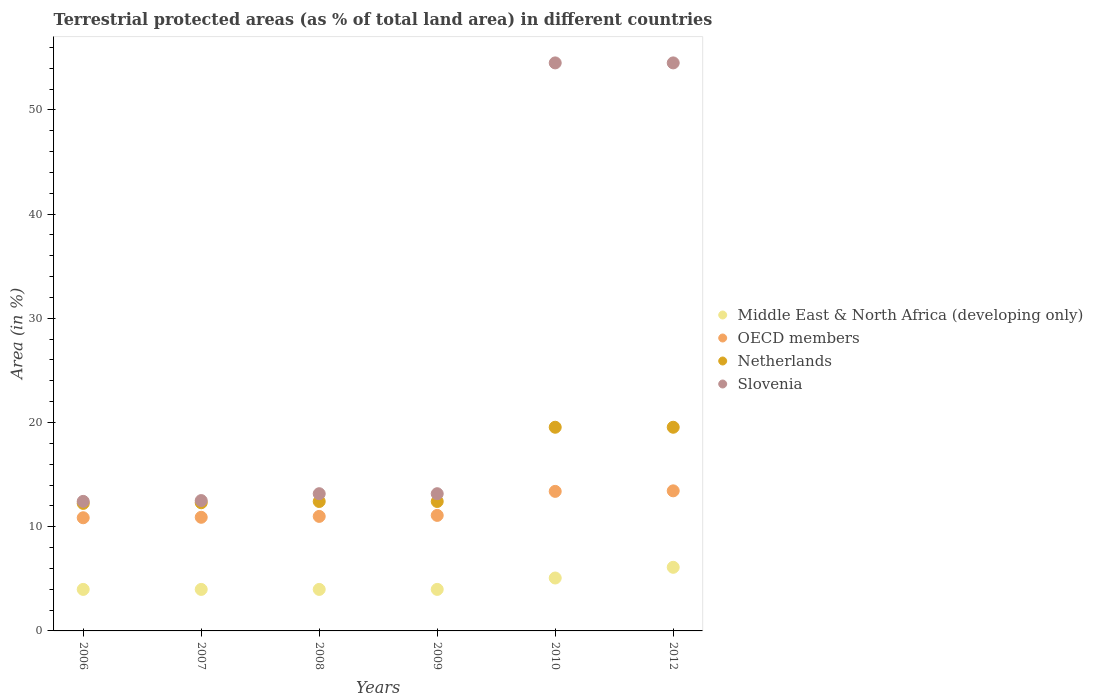What is the percentage of terrestrial protected land in Middle East & North Africa (developing only) in 2007?
Provide a succinct answer. 3.98. Across all years, what is the maximum percentage of terrestrial protected land in Slovenia?
Provide a short and direct response. 54.51. Across all years, what is the minimum percentage of terrestrial protected land in Netherlands?
Give a very brief answer. 12.24. In which year was the percentage of terrestrial protected land in Netherlands maximum?
Offer a terse response. 2010. What is the total percentage of terrestrial protected land in Slovenia in the graph?
Make the answer very short. 160.29. What is the difference between the percentage of terrestrial protected land in Netherlands in 2009 and that in 2012?
Your answer should be compact. -7.12. What is the difference between the percentage of terrestrial protected land in OECD members in 2009 and the percentage of terrestrial protected land in Slovenia in 2010?
Your answer should be compact. -43.42. What is the average percentage of terrestrial protected land in Netherlands per year?
Your answer should be very brief. 14.74. In the year 2007, what is the difference between the percentage of terrestrial protected land in Netherlands and percentage of terrestrial protected land in OECD members?
Provide a succinct answer. 1.4. In how many years, is the percentage of terrestrial protected land in Slovenia greater than 50 %?
Make the answer very short. 2. What is the ratio of the percentage of terrestrial protected land in Slovenia in 2009 to that in 2010?
Provide a succinct answer. 0.24. Is the percentage of terrestrial protected land in Middle East & North Africa (developing only) in 2009 less than that in 2010?
Provide a succinct answer. Yes. Is the difference between the percentage of terrestrial protected land in Netherlands in 2006 and 2012 greater than the difference between the percentage of terrestrial protected land in OECD members in 2006 and 2012?
Your answer should be compact. No. What is the difference between the highest and the second highest percentage of terrestrial protected land in Slovenia?
Make the answer very short. 0. What is the difference between the highest and the lowest percentage of terrestrial protected land in Slovenia?
Provide a short and direct response. 42.08. Is it the case that in every year, the sum of the percentage of terrestrial protected land in OECD members and percentage of terrestrial protected land in Netherlands  is greater than the sum of percentage of terrestrial protected land in Middle East & North Africa (developing only) and percentage of terrestrial protected land in Slovenia?
Offer a terse response. No. Is it the case that in every year, the sum of the percentage of terrestrial protected land in Slovenia and percentage of terrestrial protected land in Middle East & North Africa (developing only)  is greater than the percentage of terrestrial protected land in OECD members?
Make the answer very short. Yes. Is the percentage of terrestrial protected land in OECD members strictly greater than the percentage of terrestrial protected land in Middle East & North Africa (developing only) over the years?
Keep it short and to the point. Yes. Is the percentage of terrestrial protected land in OECD members strictly less than the percentage of terrestrial protected land in Middle East & North Africa (developing only) over the years?
Offer a very short reply. No. How many dotlines are there?
Your response must be concise. 4. How many years are there in the graph?
Your answer should be very brief. 6. What is the difference between two consecutive major ticks on the Y-axis?
Your answer should be very brief. 10. Are the values on the major ticks of Y-axis written in scientific E-notation?
Ensure brevity in your answer.  No. Where does the legend appear in the graph?
Your response must be concise. Center right. How many legend labels are there?
Your response must be concise. 4. What is the title of the graph?
Offer a terse response. Terrestrial protected areas (as % of total land area) in different countries. What is the label or title of the Y-axis?
Your answer should be very brief. Area (in %). What is the Area (in %) in Middle East & North Africa (developing only) in 2006?
Provide a short and direct response. 3.98. What is the Area (in %) of OECD members in 2006?
Provide a succinct answer. 10.86. What is the Area (in %) of Netherlands in 2006?
Make the answer very short. 12.24. What is the Area (in %) in Slovenia in 2006?
Offer a very short reply. 12.43. What is the Area (in %) in Middle East & North Africa (developing only) in 2007?
Provide a succinct answer. 3.98. What is the Area (in %) of OECD members in 2007?
Make the answer very short. 10.9. What is the Area (in %) in Netherlands in 2007?
Provide a succinct answer. 12.3. What is the Area (in %) of Slovenia in 2007?
Offer a very short reply. 12.51. What is the Area (in %) in Middle East & North Africa (developing only) in 2008?
Your answer should be compact. 3.98. What is the Area (in %) of OECD members in 2008?
Your answer should be very brief. 10.99. What is the Area (in %) of Netherlands in 2008?
Offer a very short reply. 12.42. What is the Area (in %) in Slovenia in 2008?
Keep it short and to the point. 13.17. What is the Area (in %) in Middle East & North Africa (developing only) in 2009?
Make the answer very short. 3.98. What is the Area (in %) of OECD members in 2009?
Ensure brevity in your answer.  11.09. What is the Area (in %) in Netherlands in 2009?
Your answer should be compact. 12.42. What is the Area (in %) of Slovenia in 2009?
Make the answer very short. 13.17. What is the Area (in %) of Middle East & North Africa (developing only) in 2010?
Offer a very short reply. 5.08. What is the Area (in %) in OECD members in 2010?
Give a very brief answer. 13.39. What is the Area (in %) of Netherlands in 2010?
Your response must be concise. 19.54. What is the Area (in %) of Slovenia in 2010?
Offer a terse response. 54.51. What is the Area (in %) of Middle East & North Africa (developing only) in 2012?
Your response must be concise. 6.1. What is the Area (in %) of OECD members in 2012?
Your answer should be compact. 13.44. What is the Area (in %) in Netherlands in 2012?
Provide a short and direct response. 19.54. What is the Area (in %) of Slovenia in 2012?
Make the answer very short. 54.51. Across all years, what is the maximum Area (in %) of Middle East & North Africa (developing only)?
Give a very brief answer. 6.1. Across all years, what is the maximum Area (in %) in OECD members?
Offer a terse response. 13.44. Across all years, what is the maximum Area (in %) in Netherlands?
Offer a terse response. 19.54. Across all years, what is the maximum Area (in %) in Slovenia?
Offer a terse response. 54.51. Across all years, what is the minimum Area (in %) of Middle East & North Africa (developing only)?
Offer a terse response. 3.98. Across all years, what is the minimum Area (in %) of OECD members?
Your answer should be very brief. 10.86. Across all years, what is the minimum Area (in %) in Netherlands?
Your response must be concise. 12.24. Across all years, what is the minimum Area (in %) in Slovenia?
Your response must be concise. 12.43. What is the total Area (in %) of Middle East & North Africa (developing only) in the graph?
Your response must be concise. 27.12. What is the total Area (in %) of OECD members in the graph?
Your answer should be compact. 70.67. What is the total Area (in %) of Netherlands in the graph?
Provide a succinct answer. 88.47. What is the total Area (in %) in Slovenia in the graph?
Ensure brevity in your answer.  160.29. What is the difference between the Area (in %) of Middle East & North Africa (developing only) in 2006 and that in 2007?
Provide a succinct answer. 0. What is the difference between the Area (in %) of OECD members in 2006 and that in 2007?
Give a very brief answer. -0.04. What is the difference between the Area (in %) in Netherlands in 2006 and that in 2007?
Offer a very short reply. -0.06. What is the difference between the Area (in %) of Slovenia in 2006 and that in 2007?
Make the answer very short. -0.08. What is the difference between the Area (in %) of OECD members in 2006 and that in 2008?
Your answer should be very brief. -0.13. What is the difference between the Area (in %) in Netherlands in 2006 and that in 2008?
Your response must be concise. -0.18. What is the difference between the Area (in %) in Slovenia in 2006 and that in 2008?
Make the answer very short. -0.74. What is the difference between the Area (in %) in Middle East & North Africa (developing only) in 2006 and that in 2009?
Offer a terse response. -0. What is the difference between the Area (in %) in OECD members in 2006 and that in 2009?
Your response must be concise. -0.23. What is the difference between the Area (in %) of Netherlands in 2006 and that in 2009?
Provide a succinct answer. -0.18. What is the difference between the Area (in %) of Slovenia in 2006 and that in 2009?
Provide a succinct answer. -0.74. What is the difference between the Area (in %) of Middle East & North Africa (developing only) in 2006 and that in 2010?
Your answer should be compact. -1.09. What is the difference between the Area (in %) of OECD members in 2006 and that in 2010?
Make the answer very short. -2.53. What is the difference between the Area (in %) of Netherlands in 2006 and that in 2010?
Offer a very short reply. -7.31. What is the difference between the Area (in %) of Slovenia in 2006 and that in 2010?
Provide a short and direct response. -42.08. What is the difference between the Area (in %) in Middle East & North Africa (developing only) in 2006 and that in 2012?
Make the answer very short. -2.12. What is the difference between the Area (in %) in OECD members in 2006 and that in 2012?
Offer a very short reply. -2.58. What is the difference between the Area (in %) in Netherlands in 2006 and that in 2012?
Provide a short and direct response. -7.31. What is the difference between the Area (in %) of Slovenia in 2006 and that in 2012?
Your answer should be very brief. -42.08. What is the difference between the Area (in %) in Middle East & North Africa (developing only) in 2007 and that in 2008?
Provide a short and direct response. 0. What is the difference between the Area (in %) in OECD members in 2007 and that in 2008?
Give a very brief answer. -0.09. What is the difference between the Area (in %) in Netherlands in 2007 and that in 2008?
Your response must be concise. -0.12. What is the difference between the Area (in %) in Slovenia in 2007 and that in 2008?
Your answer should be very brief. -0.66. What is the difference between the Area (in %) of Middle East & North Africa (developing only) in 2007 and that in 2009?
Provide a succinct answer. -0. What is the difference between the Area (in %) of OECD members in 2007 and that in 2009?
Your response must be concise. -0.18. What is the difference between the Area (in %) of Netherlands in 2007 and that in 2009?
Your answer should be very brief. -0.12. What is the difference between the Area (in %) of Slovenia in 2007 and that in 2009?
Provide a succinct answer. -0.66. What is the difference between the Area (in %) in Middle East & North Africa (developing only) in 2007 and that in 2010?
Give a very brief answer. -1.09. What is the difference between the Area (in %) in OECD members in 2007 and that in 2010?
Your answer should be very brief. -2.49. What is the difference between the Area (in %) of Netherlands in 2007 and that in 2010?
Your answer should be very brief. -7.25. What is the difference between the Area (in %) of Slovenia in 2007 and that in 2010?
Offer a terse response. -42. What is the difference between the Area (in %) of Middle East & North Africa (developing only) in 2007 and that in 2012?
Your answer should be compact. -2.12. What is the difference between the Area (in %) of OECD members in 2007 and that in 2012?
Your answer should be compact. -2.54. What is the difference between the Area (in %) of Netherlands in 2007 and that in 2012?
Ensure brevity in your answer.  -7.25. What is the difference between the Area (in %) of Slovenia in 2007 and that in 2012?
Your response must be concise. -42. What is the difference between the Area (in %) of Middle East & North Africa (developing only) in 2008 and that in 2009?
Provide a succinct answer. -0. What is the difference between the Area (in %) in OECD members in 2008 and that in 2009?
Offer a very short reply. -0.1. What is the difference between the Area (in %) in Netherlands in 2008 and that in 2009?
Ensure brevity in your answer.  0. What is the difference between the Area (in %) in Slovenia in 2008 and that in 2009?
Give a very brief answer. 0. What is the difference between the Area (in %) in Middle East & North Africa (developing only) in 2008 and that in 2010?
Your answer should be compact. -1.09. What is the difference between the Area (in %) in OECD members in 2008 and that in 2010?
Offer a very short reply. -2.4. What is the difference between the Area (in %) in Netherlands in 2008 and that in 2010?
Provide a succinct answer. -7.12. What is the difference between the Area (in %) in Slovenia in 2008 and that in 2010?
Offer a terse response. -41.34. What is the difference between the Area (in %) of Middle East & North Africa (developing only) in 2008 and that in 2012?
Offer a very short reply. -2.12. What is the difference between the Area (in %) of OECD members in 2008 and that in 2012?
Make the answer very short. -2.45. What is the difference between the Area (in %) in Netherlands in 2008 and that in 2012?
Keep it short and to the point. -7.12. What is the difference between the Area (in %) of Slovenia in 2008 and that in 2012?
Your answer should be compact. -41.34. What is the difference between the Area (in %) of Middle East & North Africa (developing only) in 2009 and that in 2010?
Your answer should be compact. -1.09. What is the difference between the Area (in %) of OECD members in 2009 and that in 2010?
Your response must be concise. -2.31. What is the difference between the Area (in %) in Netherlands in 2009 and that in 2010?
Provide a succinct answer. -7.12. What is the difference between the Area (in %) of Slovenia in 2009 and that in 2010?
Keep it short and to the point. -41.34. What is the difference between the Area (in %) of Middle East & North Africa (developing only) in 2009 and that in 2012?
Make the answer very short. -2.12. What is the difference between the Area (in %) in OECD members in 2009 and that in 2012?
Offer a terse response. -2.36. What is the difference between the Area (in %) in Netherlands in 2009 and that in 2012?
Keep it short and to the point. -7.12. What is the difference between the Area (in %) of Slovenia in 2009 and that in 2012?
Your response must be concise. -41.34. What is the difference between the Area (in %) of Middle East & North Africa (developing only) in 2010 and that in 2012?
Provide a short and direct response. -1.03. What is the difference between the Area (in %) in OECD members in 2010 and that in 2012?
Offer a terse response. -0.05. What is the difference between the Area (in %) in Middle East & North Africa (developing only) in 2006 and the Area (in %) in OECD members in 2007?
Keep it short and to the point. -6.92. What is the difference between the Area (in %) in Middle East & North Africa (developing only) in 2006 and the Area (in %) in Netherlands in 2007?
Ensure brevity in your answer.  -8.32. What is the difference between the Area (in %) of Middle East & North Africa (developing only) in 2006 and the Area (in %) of Slovenia in 2007?
Keep it short and to the point. -8.52. What is the difference between the Area (in %) of OECD members in 2006 and the Area (in %) of Netherlands in 2007?
Your answer should be compact. -1.44. What is the difference between the Area (in %) of OECD members in 2006 and the Area (in %) of Slovenia in 2007?
Keep it short and to the point. -1.65. What is the difference between the Area (in %) of Netherlands in 2006 and the Area (in %) of Slovenia in 2007?
Your answer should be very brief. -0.27. What is the difference between the Area (in %) in Middle East & North Africa (developing only) in 2006 and the Area (in %) in OECD members in 2008?
Your answer should be compact. -7.01. What is the difference between the Area (in %) in Middle East & North Africa (developing only) in 2006 and the Area (in %) in Netherlands in 2008?
Offer a terse response. -8.44. What is the difference between the Area (in %) in Middle East & North Africa (developing only) in 2006 and the Area (in %) in Slovenia in 2008?
Offer a terse response. -9.18. What is the difference between the Area (in %) of OECD members in 2006 and the Area (in %) of Netherlands in 2008?
Keep it short and to the point. -1.56. What is the difference between the Area (in %) of OECD members in 2006 and the Area (in %) of Slovenia in 2008?
Your response must be concise. -2.31. What is the difference between the Area (in %) of Netherlands in 2006 and the Area (in %) of Slovenia in 2008?
Provide a short and direct response. -0.93. What is the difference between the Area (in %) in Middle East & North Africa (developing only) in 2006 and the Area (in %) in OECD members in 2009?
Your answer should be very brief. -7.1. What is the difference between the Area (in %) of Middle East & North Africa (developing only) in 2006 and the Area (in %) of Netherlands in 2009?
Your response must be concise. -8.44. What is the difference between the Area (in %) in Middle East & North Africa (developing only) in 2006 and the Area (in %) in Slovenia in 2009?
Give a very brief answer. -9.18. What is the difference between the Area (in %) of OECD members in 2006 and the Area (in %) of Netherlands in 2009?
Your response must be concise. -1.56. What is the difference between the Area (in %) of OECD members in 2006 and the Area (in %) of Slovenia in 2009?
Provide a succinct answer. -2.31. What is the difference between the Area (in %) in Netherlands in 2006 and the Area (in %) in Slovenia in 2009?
Provide a succinct answer. -0.93. What is the difference between the Area (in %) of Middle East & North Africa (developing only) in 2006 and the Area (in %) of OECD members in 2010?
Ensure brevity in your answer.  -9.41. What is the difference between the Area (in %) in Middle East & North Africa (developing only) in 2006 and the Area (in %) in Netherlands in 2010?
Your response must be concise. -15.56. What is the difference between the Area (in %) of Middle East & North Africa (developing only) in 2006 and the Area (in %) of Slovenia in 2010?
Ensure brevity in your answer.  -50.53. What is the difference between the Area (in %) of OECD members in 2006 and the Area (in %) of Netherlands in 2010?
Ensure brevity in your answer.  -8.68. What is the difference between the Area (in %) of OECD members in 2006 and the Area (in %) of Slovenia in 2010?
Ensure brevity in your answer.  -43.65. What is the difference between the Area (in %) of Netherlands in 2006 and the Area (in %) of Slovenia in 2010?
Your response must be concise. -42.27. What is the difference between the Area (in %) of Middle East & North Africa (developing only) in 2006 and the Area (in %) of OECD members in 2012?
Make the answer very short. -9.46. What is the difference between the Area (in %) in Middle East & North Africa (developing only) in 2006 and the Area (in %) in Netherlands in 2012?
Offer a very short reply. -15.56. What is the difference between the Area (in %) in Middle East & North Africa (developing only) in 2006 and the Area (in %) in Slovenia in 2012?
Offer a terse response. -50.53. What is the difference between the Area (in %) in OECD members in 2006 and the Area (in %) in Netherlands in 2012?
Your answer should be very brief. -8.68. What is the difference between the Area (in %) in OECD members in 2006 and the Area (in %) in Slovenia in 2012?
Keep it short and to the point. -43.65. What is the difference between the Area (in %) in Netherlands in 2006 and the Area (in %) in Slovenia in 2012?
Give a very brief answer. -42.27. What is the difference between the Area (in %) of Middle East & North Africa (developing only) in 2007 and the Area (in %) of OECD members in 2008?
Offer a terse response. -7.01. What is the difference between the Area (in %) in Middle East & North Africa (developing only) in 2007 and the Area (in %) in Netherlands in 2008?
Give a very brief answer. -8.44. What is the difference between the Area (in %) in Middle East & North Africa (developing only) in 2007 and the Area (in %) in Slovenia in 2008?
Provide a succinct answer. -9.18. What is the difference between the Area (in %) in OECD members in 2007 and the Area (in %) in Netherlands in 2008?
Make the answer very short. -1.52. What is the difference between the Area (in %) of OECD members in 2007 and the Area (in %) of Slovenia in 2008?
Provide a succinct answer. -2.26. What is the difference between the Area (in %) of Netherlands in 2007 and the Area (in %) of Slovenia in 2008?
Offer a terse response. -0.87. What is the difference between the Area (in %) in Middle East & North Africa (developing only) in 2007 and the Area (in %) in OECD members in 2009?
Make the answer very short. -7.1. What is the difference between the Area (in %) in Middle East & North Africa (developing only) in 2007 and the Area (in %) in Netherlands in 2009?
Your answer should be very brief. -8.44. What is the difference between the Area (in %) in Middle East & North Africa (developing only) in 2007 and the Area (in %) in Slovenia in 2009?
Offer a very short reply. -9.18. What is the difference between the Area (in %) in OECD members in 2007 and the Area (in %) in Netherlands in 2009?
Offer a terse response. -1.52. What is the difference between the Area (in %) in OECD members in 2007 and the Area (in %) in Slovenia in 2009?
Keep it short and to the point. -2.26. What is the difference between the Area (in %) of Netherlands in 2007 and the Area (in %) of Slovenia in 2009?
Make the answer very short. -0.87. What is the difference between the Area (in %) of Middle East & North Africa (developing only) in 2007 and the Area (in %) of OECD members in 2010?
Make the answer very short. -9.41. What is the difference between the Area (in %) of Middle East & North Africa (developing only) in 2007 and the Area (in %) of Netherlands in 2010?
Offer a terse response. -15.56. What is the difference between the Area (in %) in Middle East & North Africa (developing only) in 2007 and the Area (in %) in Slovenia in 2010?
Provide a short and direct response. -50.53. What is the difference between the Area (in %) in OECD members in 2007 and the Area (in %) in Netherlands in 2010?
Keep it short and to the point. -8.64. What is the difference between the Area (in %) in OECD members in 2007 and the Area (in %) in Slovenia in 2010?
Give a very brief answer. -43.6. What is the difference between the Area (in %) of Netherlands in 2007 and the Area (in %) of Slovenia in 2010?
Your response must be concise. -42.21. What is the difference between the Area (in %) of Middle East & North Africa (developing only) in 2007 and the Area (in %) of OECD members in 2012?
Your answer should be very brief. -9.46. What is the difference between the Area (in %) in Middle East & North Africa (developing only) in 2007 and the Area (in %) in Netherlands in 2012?
Give a very brief answer. -15.56. What is the difference between the Area (in %) in Middle East & North Africa (developing only) in 2007 and the Area (in %) in Slovenia in 2012?
Make the answer very short. -50.53. What is the difference between the Area (in %) in OECD members in 2007 and the Area (in %) in Netherlands in 2012?
Ensure brevity in your answer.  -8.64. What is the difference between the Area (in %) of OECD members in 2007 and the Area (in %) of Slovenia in 2012?
Offer a very short reply. -43.6. What is the difference between the Area (in %) in Netherlands in 2007 and the Area (in %) in Slovenia in 2012?
Provide a succinct answer. -42.21. What is the difference between the Area (in %) in Middle East & North Africa (developing only) in 2008 and the Area (in %) in OECD members in 2009?
Ensure brevity in your answer.  -7.1. What is the difference between the Area (in %) of Middle East & North Africa (developing only) in 2008 and the Area (in %) of Netherlands in 2009?
Ensure brevity in your answer.  -8.44. What is the difference between the Area (in %) of Middle East & North Africa (developing only) in 2008 and the Area (in %) of Slovenia in 2009?
Ensure brevity in your answer.  -9.18. What is the difference between the Area (in %) in OECD members in 2008 and the Area (in %) in Netherlands in 2009?
Make the answer very short. -1.43. What is the difference between the Area (in %) in OECD members in 2008 and the Area (in %) in Slovenia in 2009?
Ensure brevity in your answer.  -2.18. What is the difference between the Area (in %) of Netherlands in 2008 and the Area (in %) of Slovenia in 2009?
Offer a very short reply. -0.75. What is the difference between the Area (in %) of Middle East & North Africa (developing only) in 2008 and the Area (in %) of OECD members in 2010?
Offer a very short reply. -9.41. What is the difference between the Area (in %) in Middle East & North Africa (developing only) in 2008 and the Area (in %) in Netherlands in 2010?
Give a very brief answer. -15.56. What is the difference between the Area (in %) in Middle East & North Africa (developing only) in 2008 and the Area (in %) in Slovenia in 2010?
Give a very brief answer. -50.53. What is the difference between the Area (in %) in OECD members in 2008 and the Area (in %) in Netherlands in 2010?
Offer a very short reply. -8.56. What is the difference between the Area (in %) in OECD members in 2008 and the Area (in %) in Slovenia in 2010?
Give a very brief answer. -43.52. What is the difference between the Area (in %) in Netherlands in 2008 and the Area (in %) in Slovenia in 2010?
Make the answer very short. -42.09. What is the difference between the Area (in %) in Middle East & North Africa (developing only) in 2008 and the Area (in %) in OECD members in 2012?
Your answer should be compact. -9.46. What is the difference between the Area (in %) in Middle East & North Africa (developing only) in 2008 and the Area (in %) in Netherlands in 2012?
Keep it short and to the point. -15.56. What is the difference between the Area (in %) of Middle East & North Africa (developing only) in 2008 and the Area (in %) of Slovenia in 2012?
Give a very brief answer. -50.53. What is the difference between the Area (in %) in OECD members in 2008 and the Area (in %) in Netherlands in 2012?
Ensure brevity in your answer.  -8.56. What is the difference between the Area (in %) of OECD members in 2008 and the Area (in %) of Slovenia in 2012?
Provide a succinct answer. -43.52. What is the difference between the Area (in %) in Netherlands in 2008 and the Area (in %) in Slovenia in 2012?
Offer a very short reply. -42.09. What is the difference between the Area (in %) in Middle East & North Africa (developing only) in 2009 and the Area (in %) in OECD members in 2010?
Make the answer very short. -9.41. What is the difference between the Area (in %) in Middle East & North Africa (developing only) in 2009 and the Area (in %) in Netherlands in 2010?
Provide a short and direct response. -15.56. What is the difference between the Area (in %) in Middle East & North Africa (developing only) in 2009 and the Area (in %) in Slovenia in 2010?
Offer a terse response. -50.52. What is the difference between the Area (in %) in OECD members in 2009 and the Area (in %) in Netherlands in 2010?
Offer a terse response. -8.46. What is the difference between the Area (in %) in OECD members in 2009 and the Area (in %) in Slovenia in 2010?
Provide a short and direct response. -43.42. What is the difference between the Area (in %) in Netherlands in 2009 and the Area (in %) in Slovenia in 2010?
Provide a succinct answer. -42.09. What is the difference between the Area (in %) in Middle East & North Africa (developing only) in 2009 and the Area (in %) in OECD members in 2012?
Your answer should be compact. -9.46. What is the difference between the Area (in %) of Middle East & North Africa (developing only) in 2009 and the Area (in %) of Netherlands in 2012?
Ensure brevity in your answer.  -15.56. What is the difference between the Area (in %) in Middle East & North Africa (developing only) in 2009 and the Area (in %) in Slovenia in 2012?
Your answer should be very brief. -50.52. What is the difference between the Area (in %) of OECD members in 2009 and the Area (in %) of Netherlands in 2012?
Give a very brief answer. -8.46. What is the difference between the Area (in %) in OECD members in 2009 and the Area (in %) in Slovenia in 2012?
Offer a very short reply. -43.42. What is the difference between the Area (in %) in Netherlands in 2009 and the Area (in %) in Slovenia in 2012?
Provide a succinct answer. -42.09. What is the difference between the Area (in %) in Middle East & North Africa (developing only) in 2010 and the Area (in %) in OECD members in 2012?
Offer a very short reply. -8.36. What is the difference between the Area (in %) of Middle East & North Africa (developing only) in 2010 and the Area (in %) of Netherlands in 2012?
Your answer should be compact. -14.47. What is the difference between the Area (in %) in Middle East & North Africa (developing only) in 2010 and the Area (in %) in Slovenia in 2012?
Make the answer very short. -49.43. What is the difference between the Area (in %) in OECD members in 2010 and the Area (in %) in Netherlands in 2012?
Offer a very short reply. -6.15. What is the difference between the Area (in %) in OECD members in 2010 and the Area (in %) in Slovenia in 2012?
Give a very brief answer. -41.12. What is the difference between the Area (in %) in Netherlands in 2010 and the Area (in %) in Slovenia in 2012?
Your response must be concise. -34.96. What is the average Area (in %) in Middle East & North Africa (developing only) per year?
Give a very brief answer. 4.52. What is the average Area (in %) in OECD members per year?
Offer a terse response. 11.78. What is the average Area (in %) in Netherlands per year?
Your response must be concise. 14.74. What is the average Area (in %) in Slovenia per year?
Your answer should be very brief. 26.71. In the year 2006, what is the difference between the Area (in %) in Middle East & North Africa (developing only) and Area (in %) in OECD members?
Your response must be concise. -6.88. In the year 2006, what is the difference between the Area (in %) in Middle East & North Africa (developing only) and Area (in %) in Netherlands?
Provide a short and direct response. -8.25. In the year 2006, what is the difference between the Area (in %) in Middle East & North Africa (developing only) and Area (in %) in Slovenia?
Your response must be concise. -8.45. In the year 2006, what is the difference between the Area (in %) of OECD members and Area (in %) of Netherlands?
Offer a very short reply. -1.38. In the year 2006, what is the difference between the Area (in %) in OECD members and Area (in %) in Slovenia?
Your answer should be compact. -1.57. In the year 2006, what is the difference between the Area (in %) of Netherlands and Area (in %) of Slovenia?
Give a very brief answer. -0.19. In the year 2007, what is the difference between the Area (in %) of Middle East & North Africa (developing only) and Area (in %) of OECD members?
Ensure brevity in your answer.  -6.92. In the year 2007, what is the difference between the Area (in %) of Middle East & North Africa (developing only) and Area (in %) of Netherlands?
Provide a short and direct response. -8.32. In the year 2007, what is the difference between the Area (in %) of Middle East & North Africa (developing only) and Area (in %) of Slovenia?
Provide a succinct answer. -8.52. In the year 2007, what is the difference between the Area (in %) of OECD members and Area (in %) of Netherlands?
Your response must be concise. -1.4. In the year 2007, what is the difference between the Area (in %) in OECD members and Area (in %) in Slovenia?
Ensure brevity in your answer.  -1.6. In the year 2007, what is the difference between the Area (in %) in Netherlands and Area (in %) in Slovenia?
Your answer should be compact. -0.21. In the year 2008, what is the difference between the Area (in %) of Middle East & North Africa (developing only) and Area (in %) of OECD members?
Your response must be concise. -7.01. In the year 2008, what is the difference between the Area (in %) in Middle East & North Africa (developing only) and Area (in %) in Netherlands?
Your answer should be compact. -8.44. In the year 2008, what is the difference between the Area (in %) of Middle East & North Africa (developing only) and Area (in %) of Slovenia?
Offer a terse response. -9.18. In the year 2008, what is the difference between the Area (in %) in OECD members and Area (in %) in Netherlands?
Keep it short and to the point. -1.43. In the year 2008, what is the difference between the Area (in %) of OECD members and Area (in %) of Slovenia?
Offer a terse response. -2.18. In the year 2008, what is the difference between the Area (in %) in Netherlands and Area (in %) in Slovenia?
Your answer should be compact. -0.75. In the year 2009, what is the difference between the Area (in %) of Middle East & North Africa (developing only) and Area (in %) of OECD members?
Ensure brevity in your answer.  -7.1. In the year 2009, what is the difference between the Area (in %) in Middle East & North Africa (developing only) and Area (in %) in Netherlands?
Keep it short and to the point. -8.44. In the year 2009, what is the difference between the Area (in %) in Middle East & North Africa (developing only) and Area (in %) in Slovenia?
Give a very brief answer. -9.18. In the year 2009, what is the difference between the Area (in %) of OECD members and Area (in %) of Netherlands?
Provide a short and direct response. -1.34. In the year 2009, what is the difference between the Area (in %) of OECD members and Area (in %) of Slovenia?
Ensure brevity in your answer.  -2.08. In the year 2009, what is the difference between the Area (in %) in Netherlands and Area (in %) in Slovenia?
Offer a terse response. -0.75. In the year 2010, what is the difference between the Area (in %) in Middle East & North Africa (developing only) and Area (in %) in OECD members?
Offer a terse response. -8.31. In the year 2010, what is the difference between the Area (in %) in Middle East & North Africa (developing only) and Area (in %) in Netherlands?
Provide a succinct answer. -14.47. In the year 2010, what is the difference between the Area (in %) in Middle East & North Africa (developing only) and Area (in %) in Slovenia?
Offer a very short reply. -49.43. In the year 2010, what is the difference between the Area (in %) in OECD members and Area (in %) in Netherlands?
Give a very brief answer. -6.15. In the year 2010, what is the difference between the Area (in %) in OECD members and Area (in %) in Slovenia?
Make the answer very short. -41.12. In the year 2010, what is the difference between the Area (in %) in Netherlands and Area (in %) in Slovenia?
Give a very brief answer. -34.96. In the year 2012, what is the difference between the Area (in %) in Middle East & North Africa (developing only) and Area (in %) in OECD members?
Ensure brevity in your answer.  -7.34. In the year 2012, what is the difference between the Area (in %) in Middle East & North Africa (developing only) and Area (in %) in Netherlands?
Your answer should be very brief. -13.44. In the year 2012, what is the difference between the Area (in %) in Middle East & North Africa (developing only) and Area (in %) in Slovenia?
Offer a very short reply. -48.4. In the year 2012, what is the difference between the Area (in %) in OECD members and Area (in %) in Netherlands?
Offer a very short reply. -6.1. In the year 2012, what is the difference between the Area (in %) in OECD members and Area (in %) in Slovenia?
Offer a terse response. -41.07. In the year 2012, what is the difference between the Area (in %) in Netherlands and Area (in %) in Slovenia?
Provide a short and direct response. -34.96. What is the ratio of the Area (in %) in Middle East & North Africa (developing only) in 2006 to that in 2007?
Offer a very short reply. 1. What is the ratio of the Area (in %) in OECD members in 2006 to that in 2007?
Provide a short and direct response. 1. What is the ratio of the Area (in %) of Netherlands in 2006 to that in 2007?
Give a very brief answer. 0.99. What is the ratio of the Area (in %) of Slovenia in 2006 to that in 2007?
Keep it short and to the point. 0.99. What is the ratio of the Area (in %) in OECD members in 2006 to that in 2008?
Your answer should be compact. 0.99. What is the ratio of the Area (in %) of Netherlands in 2006 to that in 2008?
Give a very brief answer. 0.99. What is the ratio of the Area (in %) of Slovenia in 2006 to that in 2008?
Your answer should be very brief. 0.94. What is the ratio of the Area (in %) in OECD members in 2006 to that in 2009?
Ensure brevity in your answer.  0.98. What is the ratio of the Area (in %) in Netherlands in 2006 to that in 2009?
Your answer should be very brief. 0.99. What is the ratio of the Area (in %) in Slovenia in 2006 to that in 2009?
Give a very brief answer. 0.94. What is the ratio of the Area (in %) of Middle East & North Africa (developing only) in 2006 to that in 2010?
Offer a very short reply. 0.78. What is the ratio of the Area (in %) in OECD members in 2006 to that in 2010?
Your response must be concise. 0.81. What is the ratio of the Area (in %) of Netherlands in 2006 to that in 2010?
Keep it short and to the point. 0.63. What is the ratio of the Area (in %) of Slovenia in 2006 to that in 2010?
Make the answer very short. 0.23. What is the ratio of the Area (in %) of Middle East & North Africa (developing only) in 2006 to that in 2012?
Provide a short and direct response. 0.65. What is the ratio of the Area (in %) of OECD members in 2006 to that in 2012?
Your answer should be compact. 0.81. What is the ratio of the Area (in %) in Netherlands in 2006 to that in 2012?
Offer a very short reply. 0.63. What is the ratio of the Area (in %) in Slovenia in 2006 to that in 2012?
Offer a terse response. 0.23. What is the ratio of the Area (in %) of OECD members in 2007 to that in 2008?
Offer a very short reply. 0.99. What is the ratio of the Area (in %) in Netherlands in 2007 to that in 2008?
Your answer should be very brief. 0.99. What is the ratio of the Area (in %) of Slovenia in 2007 to that in 2008?
Keep it short and to the point. 0.95. What is the ratio of the Area (in %) in Middle East & North Africa (developing only) in 2007 to that in 2009?
Your response must be concise. 1. What is the ratio of the Area (in %) in OECD members in 2007 to that in 2009?
Provide a succinct answer. 0.98. What is the ratio of the Area (in %) in Netherlands in 2007 to that in 2009?
Offer a very short reply. 0.99. What is the ratio of the Area (in %) of Slovenia in 2007 to that in 2009?
Give a very brief answer. 0.95. What is the ratio of the Area (in %) of Middle East & North Africa (developing only) in 2007 to that in 2010?
Make the answer very short. 0.78. What is the ratio of the Area (in %) of OECD members in 2007 to that in 2010?
Ensure brevity in your answer.  0.81. What is the ratio of the Area (in %) of Netherlands in 2007 to that in 2010?
Offer a very short reply. 0.63. What is the ratio of the Area (in %) of Slovenia in 2007 to that in 2010?
Provide a short and direct response. 0.23. What is the ratio of the Area (in %) of Middle East & North Africa (developing only) in 2007 to that in 2012?
Offer a very short reply. 0.65. What is the ratio of the Area (in %) in OECD members in 2007 to that in 2012?
Your answer should be very brief. 0.81. What is the ratio of the Area (in %) of Netherlands in 2007 to that in 2012?
Offer a very short reply. 0.63. What is the ratio of the Area (in %) of Slovenia in 2007 to that in 2012?
Give a very brief answer. 0.23. What is the ratio of the Area (in %) in OECD members in 2008 to that in 2009?
Your response must be concise. 0.99. What is the ratio of the Area (in %) of Netherlands in 2008 to that in 2009?
Your answer should be very brief. 1. What is the ratio of the Area (in %) in Slovenia in 2008 to that in 2009?
Ensure brevity in your answer.  1. What is the ratio of the Area (in %) of Middle East & North Africa (developing only) in 2008 to that in 2010?
Provide a short and direct response. 0.78. What is the ratio of the Area (in %) in OECD members in 2008 to that in 2010?
Keep it short and to the point. 0.82. What is the ratio of the Area (in %) of Netherlands in 2008 to that in 2010?
Your answer should be very brief. 0.64. What is the ratio of the Area (in %) of Slovenia in 2008 to that in 2010?
Ensure brevity in your answer.  0.24. What is the ratio of the Area (in %) of Middle East & North Africa (developing only) in 2008 to that in 2012?
Your answer should be very brief. 0.65. What is the ratio of the Area (in %) in OECD members in 2008 to that in 2012?
Ensure brevity in your answer.  0.82. What is the ratio of the Area (in %) in Netherlands in 2008 to that in 2012?
Give a very brief answer. 0.64. What is the ratio of the Area (in %) of Slovenia in 2008 to that in 2012?
Ensure brevity in your answer.  0.24. What is the ratio of the Area (in %) in Middle East & North Africa (developing only) in 2009 to that in 2010?
Offer a terse response. 0.78. What is the ratio of the Area (in %) in OECD members in 2009 to that in 2010?
Your answer should be compact. 0.83. What is the ratio of the Area (in %) in Netherlands in 2009 to that in 2010?
Offer a terse response. 0.64. What is the ratio of the Area (in %) of Slovenia in 2009 to that in 2010?
Make the answer very short. 0.24. What is the ratio of the Area (in %) of Middle East & North Africa (developing only) in 2009 to that in 2012?
Keep it short and to the point. 0.65. What is the ratio of the Area (in %) in OECD members in 2009 to that in 2012?
Your response must be concise. 0.82. What is the ratio of the Area (in %) of Netherlands in 2009 to that in 2012?
Offer a very short reply. 0.64. What is the ratio of the Area (in %) of Slovenia in 2009 to that in 2012?
Keep it short and to the point. 0.24. What is the ratio of the Area (in %) in Middle East & North Africa (developing only) in 2010 to that in 2012?
Give a very brief answer. 0.83. What is the difference between the highest and the second highest Area (in %) in Middle East & North Africa (developing only)?
Make the answer very short. 1.03. What is the difference between the highest and the second highest Area (in %) in OECD members?
Your response must be concise. 0.05. What is the difference between the highest and the second highest Area (in %) of Netherlands?
Offer a very short reply. 0. What is the difference between the highest and the second highest Area (in %) of Slovenia?
Give a very brief answer. 0. What is the difference between the highest and the lowest Area (in %) of Middle East & North Africa (developing only)?
Give a very brief answer. 2.12. What is the difference between the highest and the lowest Area (in %) in OECD members?
Offer a terse response. 2.58. What is the difference between the highest and the lowest Area (in %) of Netherlands?
Offer a very short reply. 7.31. What is the difference between the highest and the lowest Area (in %) of Slovenia?
Ensure brevity in your answer.  42.08. 